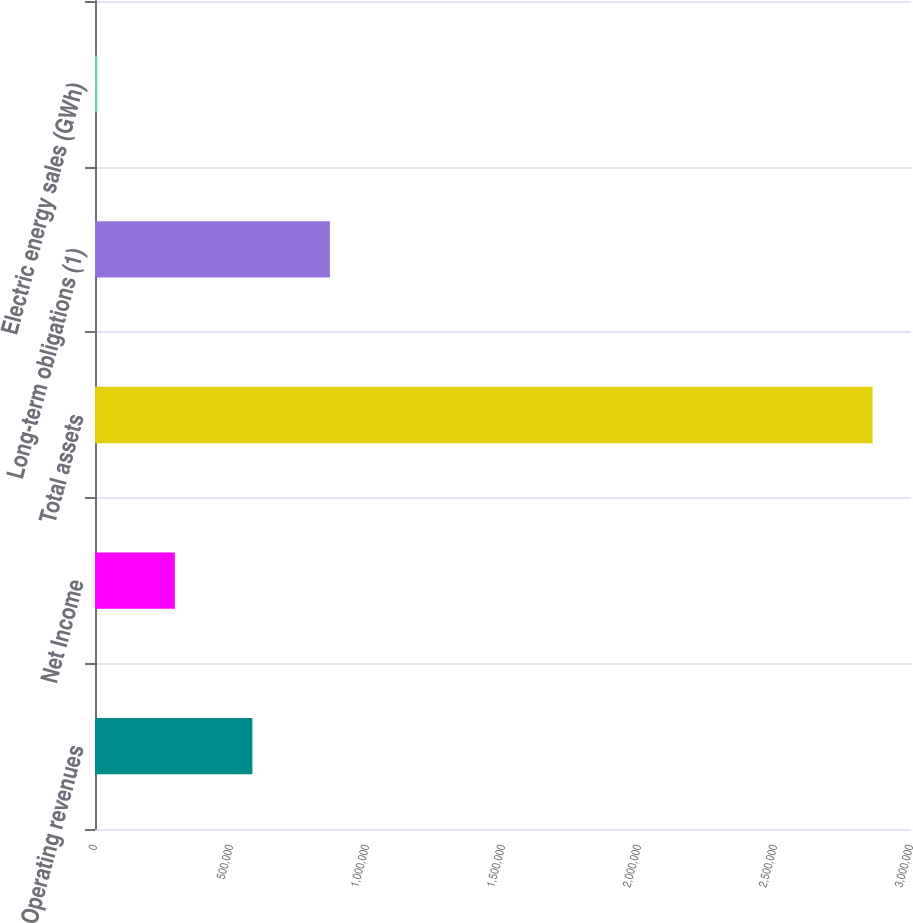<chart> <loc_0><loc_0><loc_500><loc_500><bar_chart><fcel>Operating revenues<fcel>Net Income<fcel>Total assets<fcel>Long-term obligations (1)<fcel>Electric energy sales (GWh)<nl><fcel>578504<fcel>293472<fcel>2.85876e+06<fcel>863536<fcel>8440<nl></chart> 